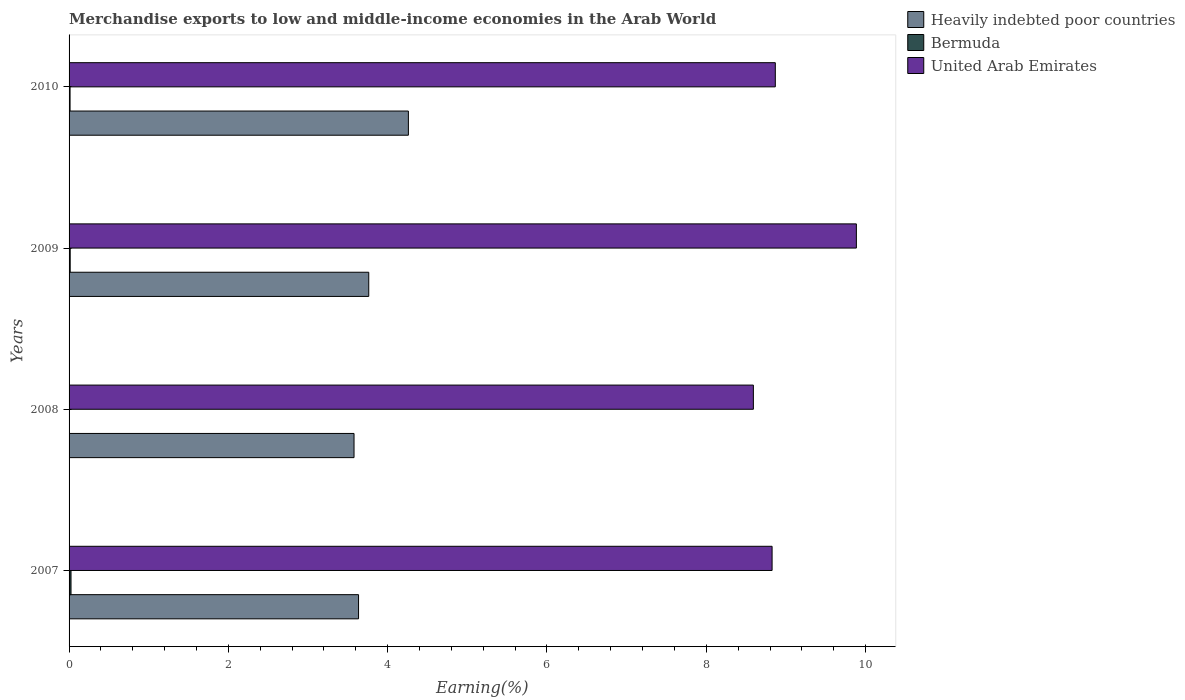How many different coloured bars are there?
Offer a terse response. 3. Are the number of bars on each tick of the Y-axis equal?
Ensure brevity in your answer.  Yes. How many bars are there on the 4th tick from the top?
Ensure brevity in your answer.  3. How many bars are there on the 2nd tick from the bottom?
Offer a very short reply. 3. What is the label of the 3rd group of bars from the top?
Keep it short and to the point. 2008. In how many cases, is the number of bars for a given year not equal to the number of legend labels?
Provide a succinct answer. 0. What is the percentage of amount earned from merchandise exports in Bermuda in 2008?
Give a very brief answer. 0. Across all years, what is the maximum percentage of amount earned from merchandise exports in Heavily indebted poor countries?
Provide a succinct answer. 4.26. Across all years, what is the minimum percentage of amount earned from merchandise exports in Heavily indebted poor countries?
Your answer should be very brief. 3.58. What is the total percentage of amount earned from merchandise exports in United Arab Emirates in the graph?
Ensure brevity in your answer.  36.17. What is the difference between the percentage of amount earned from merchandise exports in Heavily indebted poor countries in 2007 and that in 2008?
Your answer should be compact. 0.06. What is the difference between the percentage of amount earned from merchandise exports in United Arab Emirates in 2010 and the percentage of amount earned from merchandise exports in Bermuda in 2009?
Give a very brief answer. 8.85. What is the average percentage of amount earned from merchandise exports in Heavily indebted poor countries per year?
Offer a very short reply. 3.81. In the year 2010, what is the difference between the percentage of amount earned from merchandise exports in United Arab Emirates and percentage of amount earned from merchandise exports in Bermuda?
Your answer should be very brief. 8.85. In how many years, is the percentage of amount earned from merchandise exports in United Arab Emirates greater than 7.6 %?
Keep it short and to the point. 4. What is the ratio of the percentage of amount earned from merchandise exports in Heavily indebted poor countries in 2008 to that in 2010?
Provide a short and direct response. 0.84. Is the percentage of amount earned from merchandise exports in Heavily indebted poor countries in 2007 less than that in 2009?
Your response must be concise. Yes. Is the difference between the percentage of amount earned from merchandise exports in United Arab Emirates in 2007 and 2009 greater than the difference between the percentage of amount earned from merchandise exports in Bermuda in 2007 and 2009?
Give a very brief answer. No. What is the difference between the highest and the second highest percentage of amount earned from merchandise exports in United Arab Emirates?
Make the answer very short. 1.02. What is the difference between the highest and the lowest percentage of amount earned from merchandise exports in Heavily indebted poor countries?
Your response must be concise. 0.68. Is the sum of the percentage of amount earned from merchandise exports in Bermuda in 2008 and 2009 greater than the maximum percentage of amount earned from merchandise exports in Heavily indebted poor countries across all years?
Provide a short and direct response. No. What does the 2nd bar from the top in 2010 represents?
Provide a short and direct response. Bermuda. What does the 3rd bar from the bottom in 2009 represents?
Offer a terse response. United Arab Emirates. How many years are there in the graph?
Ensure brevity in your answer.  4. Are the values on the major ticks of X-axis written in scientific E-notation?
Your answer should be very brief. No. Does the graph contain any zero values?
Keep it short and to the point. No. Where does the legend appear in the graph?
Provide a short and direct response. Top right. How many legend labels are there?
Your response must be concise. 3. What is the title of the graph?
Make the answer very short. Merchandise exports to low and middle-income economies in the Arab World. Does "Malaysia" appear as one of the legend labels in the graph?
Your answer should be compact. No. What is the label or title of the X-axis?
Give a very brief answer. Earning(%). What is the label or title of the Y-axis?
Make the answer very short. Years. What is the Earning(%) in Heavily indebted poor countries in 2007?
Provide a succinct answer. 3.63. What is the Earning(%) in Bermuda in 2007?
Keep it short and to the point. 0.02. What is the Earning(%) of United Arab Emirates in 2007?
Offer a very short reply. 8.83. What is the Earning(%) of Heavily indebted poor countries in 2008?
Ensure brevity in your answer.  3.58. What is the Earning(%) in Bermuda in 2008?
Ensure brevity in your answer.  0. What is the Earning(%) of United Arab Emirates in 2008?
Make the answer very short. 8.59. What is the Earning(%) of Heavily indebted poor countries in 2009?
Make the answer very short. 3.76. What is the Earning(%) in Bermuda in 2009?
Ensure brevity in your answer.  0.01. What is the Earning(%) of United Arab Emirates in 2009?
Offer a terse response. 9.88. What is the Earning(%) of Heavily indebted poor countries in 2010?
Ensure brevity in your answer.  4.26. What is the Earning(%) of Bermuda in 2010?
Give a very brief answer. 0.01. What is the Earning(%) of United Arab Emirates in 2010?
Offer a very short reply. 8.87. Across all years, what is the maximum Earning(%) in Heavily indebted poor countries?
Offer a very short reply. 4.26. Across all years, what is the maximum Earning(%) in Bermuda?
Your answer should be very brief. 0.02. Across all years, what is the maximum Earning(%) of United Arab Emirates?
Make the answer very short. 9.88. Across all years, what is the minimum Earning(%) in Heavily indebted poor countries?
Offer a terse response. 3.58. Across all years, what is the minimum Earning(%) in Bermuda?
Your answer should be compact. 0. Across all years, what is the minimum Earning(%) in United Arab Emirates?
Offer a terse response. 8.59. What is the total Earning(%) of Heavily indebted poor countries in the graph?
Give a very brief answer. 15.23. What is the total Earning(%) of Bermuda in the graph?
Give a very brief answer. 0.06. What is the total Earning(%) of United Arab Emirates in the graph?
Ensure brevity in your answer.  36.17. What is the difference between the Earning(%) in Heavily indebted poor countries in 2007 and that in 2008?
Make the answer very short. 0.06. What is the difference between the Earning(%) of United Arab Emirates in 2007 and that in 2008?
Your answer should be very brief. 0.23. What is the difference between the Earning(%) in Heavily indebted poor countries in 2007 and that in 2009?
Your response must be concise. -0.13. What is the difference between the Earning(%) in Bermuda in 2007 and that in 2009?
Provide a short and direct response. 0.01. What is the difference between the Earning(%) in United Arab Emirates in 2007 and that in 2009?
Give a very brief answer. -1.06. What is the difference between the Earning(%) in Heavily indebted poor countries in 2007 and that in 2010?
Provide a short and direct response. -0.63. What is the difference between the Earning(%) in Bermuda in 2007 and that in 2010?
Your response must be concise. 0.01. What is the difference between the Earning(%) in United Arab Emirates in 2007 and that in 2010?
Offer a very short reply. -0.04. What is the difference between the Earning(%) of Heavily indebted poor countries in 2008 and that in 2009?
Your answer should be compact. -0.18. What is the difference between the Earning(%) in Bermuda in 2008 and that in 2009?
Provide a short and direct response. -0.01. What is the difference between the Earning(%) of United Arab Emirates in 2008 and that in 2009?
Make the answer very short. -1.29. What is the difference between the Earning(%) of Heavily indebted poor countries in 2008 and that in 2010?
Give a very brief answer. -0.68. What is the difference between the Earning(%) in Bermuda in 2008 and that in 2010?
Give a very brief answer. -0.01. What is the difference between the Earning(%) in United Arab Emirates in 2008 and that in 2010?
Make the answer very short. -0.28. What is the difference between the Earning(%) of Heavily indebted poor countries in 2009 and that in 2010?
Offer a terse response. -0.5. What is the difference between the Earning(%) in Bermuda in 2009 and that in 2010?
Make the answer very short. 0. What is the difference between the Earning(%) in United Arab Emirates in 2009 and that in 2010?
Provide a succinct answer. 1.02. What is the difference between the Earning(%) of Heavily indebted poor countries in 2007 and the Earning(%) of Bermuda in 2008?
Offer a terse response. 3.63. What is the difference between the Earning(%) of Heavily indebted poor countries in 2007 and the Earning(%) of United Arab Emirates in 2008?
Your answer should be very brief. -4.96. What is the difference between the Earning(%) in Bermuda in 2007 and the Earning(%) in United Arab Emirates in 2008?
Make the answer very short. -8.57. What is the difference between the Earning(%) in Heavily indebted poor countries in 2007 and the Earning(%) in Bermuda in 2009?
Make the answer very short. 3.62. What is the difference between the Earning(%) of Heavily indebted poor countries in 2007 and the Earning(%) of United Arab Emirates in 2009?
Ensure brevity in your answer.  -6.25. What is the difference between the Earning(%) in Bermuda in 2007 and the Earning(%) in United Arab Emirates in 2009?
Keep it short and to the point. -9.86. What is the difference between the Earning(%) of Heavily indebted poor countries in 2007 and the Earning(%) of Bermuda in 2010?
Your answer should be very brief. 3.62. What is the difference between the Earning(%) of Heavily indebted poor countries in 2007 and the Earning(%) of United Arab Emirates in 2010?
Your response must be concise. -5.23. What is the difference between the Earning(%) of Bermuda in 2007 and the Earning(%) of United Arab Emirates in 2010?
Make the answer very short. -8.84. What is the difference between the Earning(%) in Heavily indebted poor countries in 2008 and the Earning(%) in Bermuda in 2009?
Offer a very short reply. 3.56. What is the difference between the Earning(%) of Heavily indebted poor countries in 2008 and the Earning(%) of United Arab Emirates in 2009?
Ensure brevity in your answer.  -6.31. What is the difference between the Earning(%) of Bermuda in 2008 and the Earning(%) of United Arab Emirates in 2009?
Ensure brevity in your answer.  -9.88. What is the difference between the Earning(%) in Heavily indebted poor countries in 2008 and the Earning(%) in Bermuda in 2010?
Give a very brief answer. 3.57. What is the difference between the Earning(%) in Heavily indebted poor countries in 2008 and the Earning(%) in United Arab Emirates in 2010?
Provide a short and direct response. -5.29. What is the difference between the Earning(%) of Bermuda in 2008 and the Earning(%) of United Arab Emirates in 2010?
Your answer should be very brief. -8.86. What is the difference between the Earning(%) of Heavily indebted poor countries in 2009 and the Earning(%) of Bermuda in 2010?
Offer a very short reply. 3.75. What is the difference between the Earning(%) of Heavily indebted poor countries in 2009 and the Earning(%) of United Arab Emirates in 2010?
Provide a short and direct response. -5.1. What is the difference between the Earning(%) in Bermuda in 2009 and the Earning(%) in United Arab Emirates in 2010?
Offer a very short reply. -8.85. What is the average Earning(%) in Heavily indebted poor countries per year?
Give a very brief answer. 3.81. What is the average Earning(%) of Bermuda per year?
Give a very brief answer. 0.01. What is the average Earning(%) in United Arab Emirates per year?
Offer a terse response. 9.04. In the year 2007, what is the difference between the Earning(%) of Heavily indebted poor countries and Earning(%) of Bermuda?
Your response must be concise. 3.61. In the year 2007, what is the difference between the Earning(%) of Heavily indebted poor countries and Earning(%) of United Arab Emirates?
Provide a succinct answer. -5.19. In the year 2007, what is the difference between the Earning(%) of Bermuda and Earning(%) of United Arab Emirates?
Your response must be concise. -8.8. In the year 2008, what is the difference between the Earning(%) of Heavily indebted poor countries and Earning(%) of Bermuda?
Provide a short and direct response. 3.57. In the year 2008, what is the difference between the Earning(%) in Heavily indebted poor countries and Earning(%) in United Arab Emirates?
Provide a succinct answer. -5.01. In the year 2008, what is the difference between the Earning(%) in Bermuda and Earning(%) in United Arab Emirates?
Offer a terse response. -8.59. In the year 2009, what is the difference between the Earning(%) of Heavily indebted poor countries and Earning(%) of Bermuda?
Make the answer very short. 3.75. In the year 2009, what is the difference between the Earning(%) in Heavily indebted poor countries and Earning(%) in United Arab Emirates?
Keep it short and to the point. -6.12. In the year 2009, what is the difference between the Earning(%) of Bermuda and Earning(%) of United Arab Emirates?
Ensure brevity in your answer.  -9.87. In the year 2010, what is the difference between the Earning(%) in Heavily indebted poor countries and Earning(%) in Bermuda?
Your response must be concise. 4.25. In the year 2010, what is the difference between the Earning(%) in Heavily indebted poor countries and Earning(%) in United Arab Emirates?
Offer a very short reply. -4.61. In the year 2010, what is the difference between the Earning(%) in Bermuda and Earning(%) in United Arab Emirates?
Give a very brief answer. -8.85. What is the ratio of the Earning(%) of Heavily indebted poor countries in 2007 to that in 2008?
Offer a terse response. 1.02. What is the ratio of the Earning(%) of Bermuda in 2007 to that in 2008?
Offer a very short reply. 5.64. What is the ratio of the Earning(%) of United Arab Emirates in 2007 to that in 2008?
Offer a very short reply. 1.03. What is the ratio of the Earning(%) of Bermuda in 2007 to that in 2009?
Provide a short and direct response. 1.73. What is the ratio of the Earning(%) of United Arab Emirates in 2007 to that in 2009?
Offer a very short reply. 0.89. What is the ratio of the Earning(%) of Heavily indebted poor countries in 2007 to that in 2010?
Provide a short and direct response. 0.85. What is the ratio of the Earning(%) in Bermuda in 2007 to that in 2010?
Offer a terse response. 1.96. What is the ratio of the Earning(%) in Heavily indebted poor countries in 2008 to that in 2009?
Offer a terse response. 0.95. What is the ratio of the Earning(%) in Bermuda in 2008 to that in 2009?
Offer a terse response. 0.31. What is the ratio of the Earning(%) of United Arab Emirates in 2008 to that in 2009?
Make the answer very short. 0.87. What is the ratio of the Earning(%) in Heavily indebted poor countries in 2008 to that in 2010?
Give a very brief answer. 0.84. What is the ratio of the Earning(%) of Bermuda in 2008 to that in 2010?
Offer a very short reply. 0.35. What is the ratio of the Earning(%) in United Arab Emirates in 2008 to that in 2010?
Your response must be concise. 0.97. What is the ratio of the Earning(%) in Heavily indebted poor countries in 2009 to that in 2010?
Your answer should be very brief. 0.88. What is the ratio of the Earning(%) of Bermuda in 2009 to that in 2010?
Make the answer very short. 1.13. What is the ratio of the Earning(%) of United Arab Emirates in 2009 to that in 2010?
Your response must be concise. 1.11. What is the difference between the highest and the second highest Earning(%) of Heavily indebted poor countries?
Make the answer very short. 0.5. What is the difference between the highest and the second highest Earning(%) of Bermuda?
Give a very brief answer. 0.01. What is the difference between the highest and the second highest Earning(%) of United Arab Emirates?
Offer a very short reply. 1.02. What is the difference between the highest and the lowest Earning(%) of Heavily indebted poor countries?
Your answer should be very brief. 0.68. What is the difference between the highest and the lowest Earning(%) of Bermuda?
Your answer should be very brief. 0.02. What is the difference between the highest and the lowest Earning(%) of United Arab Emirates?
Ensure brevity in your answer.  1.29. 